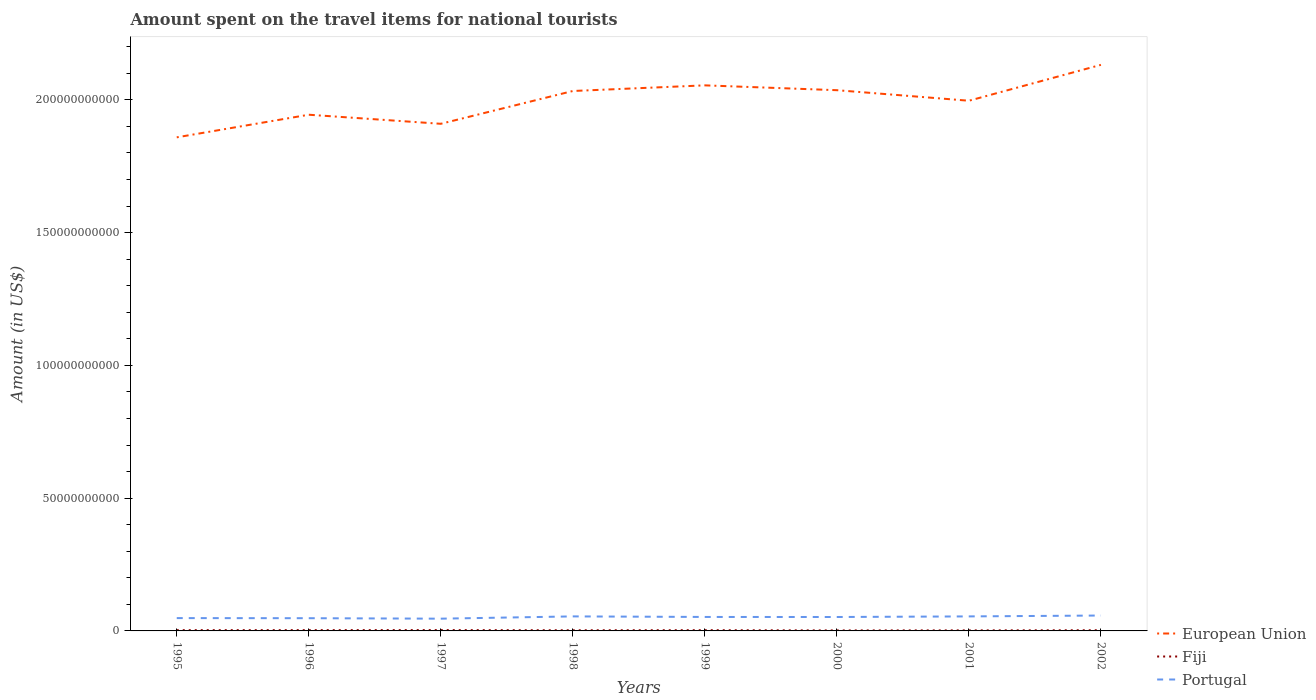How many different coloured lines are there?
Offer a very short reply. 3. Does the line corresponding to European Union intersect with the line corresponding to Portugal?
Offer a very short reply. No. Across all years, what is the maximum amount spent on the travel items for national tourists in Fiji?
Your answer should be compact. 1.89e+08. What is the total amount spent on the travel items for national tourists in European Union in the graph?
Provide a short and direct response. -8.68e+09. What is the difference between the highest and the second highest amount spent on the travel items for national tourists in Portugal?
Give a very brief answer. 1.18e+09. Is the amount spent on the travel items for national tourists in European Union strictly greater than the amount spent on the travel items for national tourists in Portugal over the years?
Your answer should be very brief. No. How many years are there in the graph?
Keep it short and to the point. 8. What is the difference between two consecutive major ticks on the Y-axis?
Provide a short and direct response. 5.00e+1. Does the graph contain grids?
Provide a short and direct response. No. Where does the legend appear in the graph?
Give a very brief answer. Bottom right. What is the title of the graph?
Provide a short and direct response. Amount spent on the travel items for national tourists. What is the label or title of the Y-axis?
Your answer should be very brief. Amount (in US$). What is the Amount (in US$) in European Union in 1995?
Provide a succinct answer. 1.86e+11. What is the Amount (in US$) of Fiji in 1995?
Provide a succinct answer. 2.91e+08. What is the Amount (in US$) in Portugal in 1995?
Your response must be concise. 4.83e+09. What is the Amount (in US$) of European Union in 1996?
Your answer should be compact. 1.94e+11. What is the Amount (in US$) in Fiji in 1996?
Provide a short and direct response. 2.98e+08. What is the Amount (in US$) of Portugal in 1996?
Give a very brief answer. 4.79e+09. What is the Amount (in US$) of European Union in 1997?
Give a very brief answer. 1.91e+11. What is the Amount (in US$) of Fiji in 1997?
Offer a terse response. 3.17e+08. What is the Amount (in US$) of Portugal in 1997?
Provide a short and direct response. 4.61e+09. What is the Amount (in US$) in European Union in 1998?
Keep it short and to the point. 2.03e+11. What is the Amount (in US$) of Fiji in 1998?
Your response must be concise. 2.48e+08. What is the Amount (in US$) in Portugal in 1998?
Offer a very short reply. 5.47e+09. What is the Amount (in US$) in European Union in 1999?
Your answer should be very brief. 2.05e+11. What is the Amount (in US$) in Fiji in 1999?
Your response must be concise. 2.80e+08. What is the Amount (in US$) in Portugal in 1999?
Keep it short and to the point. 5.26e+09. What is the Amount (in US$) in European Union in 2000?
Provide a succinct answer. 2.04e+11. What is the Amount (in US$) in Fiji in 2000?
Offer a terse response. 1.89e+08. What is the Amount (in US$) of Portugal in 2000?
Keep it short and to the point. 5.24e+09. What is the Amount (in US$) of European Union in 2001?
Keep it short and to the point. 2.00e+11. What is the Amount (in US$) in Fiji in 2001?
Your answer should be compact. 2.05e+08. What is the Amount (in US$) of Portugal in 2001?
Provide a succinct answer. 5.47e+09. What is the Amount (in US$) in European Union in 2002?
Make the answer very short. 2.13e+11. What is the Amount (in US$) in Fiji in 2002?
Provide a short and direct response. 2.60e+08. What is the Amount (in US$) in Portugal in 2002?
Your answer should be compact. 5.80e+09. Across all years, what is the maximum Amount (in US$) in European Union?
Give a very brief answer. 2.13e+11. Across all years, what is the maximum Amount (in US$) in Fiji?
Make the answer very short. 3.17e+08. Across all years, what is the maximum Amount (in US$) of Portugal?
Provide a succinct answer. 5.80e+09. Across all years, what is the minimum Amount (in US$) of European Union?
Keep it short and to the point. 1.86e+11. Across all years, what is the minimum Amount (in US$) of Fiji?
Keep it short and to the point. 1.89e+08. Across all years, what is the minimum Amount (in US$) in Portugal?
Provide a succinct answer. 4.61e+09. What is the total Amount (in US$) in European Union in the graph?
Ensure brevity in your answer.  1.60e+12. What is the total Amount (in US$) of Fiji in the graph?
Provide a succinct answer. 2.09e+09. What is the total Amount (in US$) in Portugal in the graph?
Offer a terse response. 4.15e+1. What is the difference between the Amount (in US$) in European Union in 1995 and that in 1996?
Provide a succinct answer. -8.51e+09. What is the difference between the Amount (in US$) of Fiji in 1995 and that in 1996?
Provide a succinct answer. -7.00e+06. What is the difference between the Amount (in US$) in Portugal in 1995 and that in 1996?
Your response must be concise. 4.00e+07. What is the difference between the Amount (in US$) of European Union in 1995 and that in 1997?
Provide a succinct answer. -5.10e+09. What is the difference between the Amount (in US$) of Fiji in 1995 and that in 1997?
Your answer should be very brief. -2.60e+07. What is the difference between the Amount (in US$) in Portugal in 1995 and that in 1997?
Provide a succinct answer. 2.17e+08. What is the difference between the Amount (in US$) in European Union in 1995 and that in 1998?
Provide a short and direct response. -1.75e+1. What is the difference between the Amount (in US$) of Fiji in 1995 and that in 1998?
Offer a terse response. 4.30e+07. What is the difference between the Amount (in US$) in Portugal in 1995 and that in 1998?
Your answer should be compact. -6.39e+08. What is the difference between the Amount (in US$) of European Union in 1995 and that in 1999?
Ensure brevity in your answer.  -1.96e+1. What is the difference between the Amount (in US$) of Fiji in 1995 and that in 1999?
Make the answer very short. 1.10e+07. What is the difference between the Amount (in US$) of Portugal in 1995 and that in 1999?
Offer a terse response. -4.29e+08. What is the difference between the Amount (in US$) in European Union in 1995 and that in 2000?
Keep it short and to the point. -1.78e+1. What is the difference between the Amount (in US$) in Fiji in 1995 and that in 2000?
Your response must be concise. 1.02e+08. What is the difference between the Amount (in US$) in Portugal in 1995 and that in 2000?
Your answer should be very brief. -4.12e+08. What is the difference between the Amount (in US$) in European Union in 1995 and that in 2001?
Give a very brief answer. -1.38e+1. What is the difference between the Amount (in US$) of Fiji in 1995 and that in 2001?
Make the answer very short. 8.60e+07. What is the difference between the Amount (in US$) in Portugal in 1995 and that in 2001?
Provide a short and direct response. -6.37e+08. What is the difference between the Amount (in US$) in European Union in 1995 and that in 2002?
Offer a terse response. -2.73e+1. What is the difference between the Amount (in US$) in Fiji in 1995 and that in 2002?
Keep it short and to the point. 3.10e+07. What is the difference between the Amount (in US$) of Portugal in 1995 and that in 2002?
Give a very brief answer. -9.67e+08. What is the difference between the Amount (in US$) of European Union in 1996 and that in 1997?
Offer a very short reply. 3.41e+09. What is the difference between the Amount (in US$) of Fiji in 1996 and that in 1997?
Keep it short and to the point. -1.90e+07. What is the difference between the Amount (in US$) in Portugal in 1996 and that in 1997?
Offer a terse response. 1.77e+08. What is the difference between the Amount (in US$) of European Union in 1996 and that in 1998?
Make the answer very short. -8.94e+09. What is the difference between the Amount (in US$) of Portugal in 1996 and that in 1998?
Provide a succinct answer. -6.79e+08. What is the difference between the Amount (in US$) in European Union in 1996 and that in 1999?
Offer a terse response. -1.11e+1. What is the difference between the Amount (in US$) in Fiji in 1996 and that in 1999?
Your answer should be very brief. 1.80e+07. What is the difference between the Amount (in US$) of Portugal in 1996 and that in 1999?
Your answer should be compact. -4.69e+08. What is the difference between the Amount (in US$) of European Union in 1996 and that in 2000?
Your answer should be compact. -9.24e+09. What is the difference between the Amount (in US$) in Fiji in 1996 and that in 2000?
Your response must be concise. 1.09e+08. What is the difference between the Amount (in US$) in Portugal in 1996 and that in 2000?
Keep it short and to the point. -4.52e+08. What is the difference between the Amount (in US$) in European Union in 1996 and that in 2001?
Provide a succinct answer. -5.27e+09. What is the difference between the Amount (in US$) in Fiji in 1996 and that in 2001?
Give a very brief answer. 9.30e+07. What is the difference between the Amount (in US$) of Portugal in 1996 and that in 2001?
Offer a terse response. -6.77e+08. What is the difference between the Amount (in US$) in European Union in 1996 and that in 2002?
Ensure brevity in your answer.  -1.88e+1. What is the difference between the Amount (in US$) of Fiji in 1996 and that in 2002?
Provide a succinct answer. 3.80e+07. What is the difference between the Amount (in US$) in Portugal in 1996 and that in 2002?
Offer a very short reply. -1.01e+09. What is the difference between the Amount (in US$) in European Union in 1997 and that in 1998?
Ensure brevity in your answer.  -1.24e+1. What is the difference between the Amount (in US$) of Fiji in 1997 and that in 1998?
Your response must be concise. 6.90e+07. What is the difference between the Amount (in US$) in Portugal in 1997 and that in 1998?
Offer a terse response. -8.56e+08. What is the difference between the Amount (in US$) in European Union in 1997 and that in 1999?
Ensure brevity in your answer.  -1.45e+1. What is the difference between the Amount (in US$) of Fiji in 1997 and that in 1999?
Provide a succinct answer. 3.70e+07. What is the difference between the Amount (in US$) of Portugal in 1997 and that in 1999?
Your answer should be compact. -6.46e+08. What is the difference between the Amount (in US$) of European Union in 1997 and that in 2000?
Give a very brief answer. -1.27e+1. What is the difference between the Amount (in US$) of Fiji in 1997 and that in 2000?
Make the answer very short. 1.28e+08. What is the difference between the Amount (in US$) of Portugal in 1997 and that in 2000?
Your answer should be very brief. -6.29e+08. What is the difference between the Amount (in US$) of European Union in 1997 and that in 2001?
Ensure brevity in your answer.  -8.68e+09. What is the difference between the Amount (in US$) of Fiji in 1997 and that in 2001?
Provide a short and direct response. 1.12e+08. What is the difference between the Amount (in US$) of Portugal in 1997 and that in 2001?
Keep it short and to the point. -8.54e+08. What is the difference between the Amount (in US$) of European Union in 1997 and that in 2002?
Make the answer very short. -2.22e+1. What is the difference between the Amount (in US$) in Fiji in 1997 and that in 2002?
Offer a terse response. 5.70e+07. What is the difference between the Amount (in US$) of Portugal in 1997 and that in 2002?
Ensure brevity in your answer.  -1.18e+09. What is the difference between the Amount (in US$) of European Union in 1998 and that in 1999?
Make the answer very short. -2.12e+09. What is the difference between the Amount (in US$) in Fiji in 1998 and that in 1999?
Make the answer very short. -3.20e+07. What is the difference between the Amount (in US$) of Portugal in 1998 and that in 1999?
Give a very brief answer. 2.10e+08. What is the difference between the Amount (in US$) in European Union in 1998 and that in 2000?
Your answer should be compact. -3.02e+08. What is the difference between the Amount (in US$) in Fiji in 1998 and that in 2000?
Keep it short and to the point. 5.90e+07. What is the difference between the Amount (in US$) of Portugal in 1998 and that in 2000?
Ensure brevity in your answer.  2.27e+08. What is the difference between the Amount (in US$) in European Union in 1998 and that in 2001?
Provide a succinct answer. 3.67e+09. What is the difference between the Amount (in US$) of Fiji in 1998 and that in 2001?
Your answer should be compact. 4.30e+07. What is the difference between the Amount (in US$) of European Union in 1998 and that in 2002?
Provide a succinct answer. -9.84e+09. What is the difference between the Amount (in US$) of Fiji in 1998 and that in 2002?
Keep it short and to the point. -1.20e+07. What is the difference between the Amount (in US$) of Portugal in 1998 and that in 2002?
Give a very brief answer. -3.28e+08. What is the difference between the Amount (in US$) in European Union in 1999 and that in 2000?
Your response must be concise. 1.82e+09. What is the difference between the Amount (in US$) in Fiji in 1999 and that in 2000?
Give a very brief answer. 9.10e+07. What is the difference between the Amount (in US$) of Portugal in 1999 and that in 2000?
Ensure brevity in your answer.  1.70e+07. What is the difference between the Amount (in US$) in European Union in 1999 and that in 2001?
Offer a terse response. 5.79e+09. What is the difference between the Amount (in US$) of Fiji in 1999 and that in 2001?
Make the answer very short. 7.50e+07. What is the difference between the Amount (in US$) in Portugal in 1999 and that in 2001?
Your response must be concise. -2.08e+08. What is the difference between the Amount (in US$) in European Union in 1999 and that in 2002?
Offer a terse response. -7.72e+09. What is the difference between the Amount (in US$) of Fiji in 1999 and that in 2002?
Offer a very short reply. 2.00e+07. What is the difference between the Amount (in US$) in Portugal in 1999 and that in 2002?
Provide a short and direct response. -5.38e+08. What is the difference between the Amount (in US$) in European Union in 2000 and that in 2001?
Your response must be concise. 3.97e+09. What is the difference between the Amount (in US$) in Fiji in 2000 and that in 2001?
Your response must be concise. -1.60e+07. What is the difference between the Amount (in US$) of Portugal in 2000 and that in 2001?
Offer a very short reply. -2.25e+08. What is the difference between the Amount (in US$) in European Union in 2000 and that in 2002?
Ensure brevity in your answer.  -9.54e+09. What is the difference between the Amount (in US$) of Fiji in 2000 and that in 2002?
Provide a short and direct response. -7.10e+07. What is the difference between the Amount (in US$) in Portugal in 2000 and that in 2002?
Provide a short and direct response. -5.55e+08. What is the difference between the Amount (in US$) in European Union in 2001 and that in 2002?
Provide a succinct answer. -1.35e+1. What is the difference between the Amount (in US$) of Fiji in 2001 and that in 2002?
Your answer should be compact. -5.50e+07. What is the difference between the Amount (in US$) of Portugal in 2001 and that in 2002?
Offer a terse response. -3.30e+08. What is the difference between the Amount (in US$) of European Union in 1995 and the Amount (in US$) of Fiji in 1996?
Your answer should be compact. 1.86e+11. What is the difference between the Amount (in US$) of European Union in 1995 and the Amount (in US$) of Portugal in 1996?
Offer a very short reply. 1.81e+11. What is the difference between the Amount (in US$) of Fiji in 1995 and the Amount (in US$) of Portugal in 1996?
Offer a terse response. -4.50e+09. What is the difference between the Amount (in US$) of European Union in 1995 and the Amount (in US$) of Fiji in 1997?
Provide a short and direct response. 1.86e+11. What is the difference between the Amount (in US$) in European Union in 1995 and the Amount (in US$) in Portugal in 1997?
Provide a short and direct response. 1.81e+11. What is the difference between the Amount (in US$) of Fiji in 1995 and the Amount (in US$) of Portugal in 1997?
Offer a very short reply. -4.32e+09. What is the difference between the Amount (in US$) of European Union in 1995 and the Amount (in US$) of Fiji in 1998?
Ensure brevity in your answer.  1.86e+11. What is the difference between the Amount (in US$) in European Union in 1995 and the Amount (in US$) in Portugal in 1998?
Keep it short and to the point. 1.80e+11. What is the difference between the Amount (in US$) of Fiji in 1995 and the Amount (in US$) of Portugal in 1998?
Offer a very short reply. -5.18e+09. What is the difference between the Amount (in US$) of European Union in 1995 and the Amount (in US$) of Fiji in 1999?
Offer a terse response. 1.86e+11. What is the difference between the Amount (in US$) in European Union in 1995 and the Amount (in US$) in Portugal in 1999?
Your response must be concise. 1.81e+11. What is the difference between the Amount (in US$) in Fiji in 1995 and the Amount (in US$) in Portugal in 1999?
Offer a very short reply. -4.97e+09. What is the difference between the Amount (in US$) of European Union in 1995 and the Amount (in US$) of Fiji in 2000?
Provide a succinct answer. 1.86e+11. What is the difference between the Amount (in US$) in European Union in 1995 and the Amount (in US$) in Portugal in 2000?
Your response must be concise. 1.81e+11. What is the difference between the Amount (in US$) of Fiji in 1995 and the Amount (in US$) of Portugal in 2000?
Make the answer very short. -4.95e+09. What is the difference between the Amount (in US$) in European Union in 1995 and the Amount (in US$) in Fiji in 2001?
Your answer should be very brief. 1.86e+11. What is the difference between the Amount (in US$) in European Union in 1995 and the Amount (in US$) in Portugal in 2001?
Your answer should be compact. 1.80e+11. What is the difference between the Amount (in US$) of Fiji in 1995 and the Amount (in US$) of Portugal in 2001?
Your response must be concise. -5.18e+09. What is the difference between the Amount (in US$) in European Union in 1995 and the Amount (in US$) in Fiji in 2002?
Provide a succinct answer. 1.86e+11. What is the difference between the Amount (in US$) in European Union in 1995 and the Amount (in US$) in Portugal in 2002?
Your answer should be compact. 1.80e+11. What is the difference between the Amount (in US$) of Fiji in 1995 and the Amount (in US$) of Portugal in 2002?
Your answer should be compact. -5.51e+09. What is the difference between the Amount (in US$) in European Union in 1996 and the Amount (in US$) in Fiji in 1997?
Ensure brevity in your answer.  1.94e+11. What is the difference between the Amount (in US$) of European Union in 1996 and the Amount (in US$) of Portugal in 1997?
Make the answer very short. 1.90e+11. What is the difference between the Amount (in US$) in Fiji in 1996 and the Amount (in US$) in Portugal in 1997?
Offer a very short reply. -4.32e+09. What is the difference between the Amount (in US$) in European Union in 1996 and the Amount (in US$) in Fiji in 1998?
Provide a succinct answer. 1.94e+11. What is the difference between the Amount (in US$) in European Union in 1996 and the Amount (in US$) in Portugal in 1998?
Keep it short and to the point. 1.89e+11. What is the difference between the Amount (in US$) in Fiji in 1996 and the Amount (in US$) in Portugal in 1998?
Your response must be concise. -5.17e+09. What is the difference between the Amount (in US$) in European Union in 1996 and the Amount (in US$) in Fiji in 1999?
Keep it short and to the point. 1.94e+11. What is the difference between the Amount (in US$) in European Union in 1996 and the Amount (in US$) in Portugal in 1999?
Your answer should be very brief. 1.89e+11. What is the difference between the Amount (in US$) of Fiji in 1996 and the Amount (in US$) of Portugal in 1999?
Ensure brevity in your answer.  -4.96e+09. What is the difference between the Amount (in US$) of European Union in 1996 and the Amount (in US$) of Fiji in 2000?
Your answer should be very brief. 1.94e+11. What is the difference between the Amount (in US$) in European Union in 1996 and the Amount (in US$) in Portugal in 2000?
Offer a very short reply. 1.89e+11. What is the difference between the Amount (in US$) of Fiji in 1996 and the Amount (in US$) of Portugal in 2000?
Your response must be concise. -4.94e+09. What is the difference between the Amount (in US$) in European Union in 1996 and the Amount (in US$) in Fiji in 2001?
Keep it short and to the point. 1.94e+11. What is the difference between the Amount (in US$) of European Union in 1996 and the Amount (in US$) of Portugal in 2001?
Give a very brief answer. 1.89e+11. What is the difference between the Amount (in US$) in Fiji in 1996 and the Amount (in US$) in Portugal in 2001?
Offer a terse response. -5.17e+09. What is the difference between the Amount (in US$) of European Union in 1996 and the Amount (in US$) of Fiji in 2002?
Provide a short and direct response. 1.94e+11. What is the difference between the Amount (in US$) of European Union in 1996 and the Amount (in US$) of Portugal in 2002?
Your answer should be very brief. 1.89e+11. What is the difference between the Amount (in US$) in Fiji in 1996 and the Amount (in US$) in Portugal in 2002?
Ensure brevity in your answer.  -5.50e+09. What is the difference between the Amount (in US$) in European Union in 1997 and the Amount (in US$) in Fiji in 1998?
Offer a very short reply. 1.91e+11. What is the difference between the Amount (in US$) in European Union in 1997 and the Amount (in US$) in Portugal in 1998?
Provide a short and direct response. 1.86e+11. What is the difference between the Amount (in US$) in Fiji in 1997 and the Amount (in US$) in Portugal in 1998?
Your answer should be compact. -5.15e+09. What is the difference between the Amount (in US$) of European Union in 1997 and the Amount (in US$) of Fiji in 1999?
Offer a terse response. 1.91e+11. What is the difference between the Amount (in US$) in European Union in 1997 and the Amount (in US$) in Portugal in 1999?
Make the answer very short. 1.86e+11. What is the difference between the Amount (in US$) in Fiji in 1997 and the Amount (in US$) in Portugal in 1999?
Offer a very short reply. -4.94e+09. What is the difference between the Amount (in US$) in European Union in 1997 and the Amount (in US$) in Fiji in 2000?
Offer a very short reply. 1.91e+11. What is the difference between the Amount (in US$) of European Union in 1997 and the Amount (in US$) of Portugal in 2000?
Keep it short and to the point. 1.86e+11. What is the difference between the Amount (in US$) of Fiji in 1997 and the Amount (in US$) of Portugal in 2000?
Offer a very short reply. -4.93e+09. What is the difference between the Amount (in US$) in European Union in 1997 and the Amount (in US$) in Fiji in 2001?
Make the answer very short. 1.91e+11. What is the difference between the Amount (in US$) of European Union in 1997 and the Amount (in US$) of Portugal in 2001?
Provide a succinct answer. 1.86e+11. What is the difference between the Amount (in US$) of Fiji in 1997 and the Amount (in US$) of Portugal in 2001?
Offer a very short reply. -5.15e+09. What is the difference between the Amount (in US$) of European Union in 1997 and the Amount (in US$) of Fiji in 2002?
Give a very brief answer. 1.91e+11. What is the difference between the Amount (in US$) of European Union in 1997 and the Amount (in US$) of Portugal in 2002?
Provide a succinct answer. 1.85e+11. What is the difference between the Amount (in US$) of Fiji in 1997 and the Amount (in US$) of Portugal in 2002?
Offer a very short reply. -5.48e+09. What is the difference between the Amount (in US$) of European Union in 1998 and the Amount (in US$) of Fiji in 1999?
Provide a short and direct response. 2.03e+11. What is the difference between the Amount (in US$) in European Union in 1998 and the Amount (in US$) in Portugal in 1999?
Your response must be concise. 1.98e+11. What is the difference between the Amount (in US$) in Fiji in 1998 and the Amount (in US$) in Portugal in 1999?
Your answer should be compact. -5.01e+09. What is the difference between the Amount (in US$) in European Union in 1998 and the Amount (in US$) in Fiji in 2000?
Ensure brevity in your answer.  2.03e+11. What is the difference between the Amount (in US$) of European Union in 1998 and the Amount (in US$) of Portugal in 2000?
Keep it short and to the point. 1.98e+11. What is the difference between the Amount (in US$) of Fiji in 1998 and the Amount (in US$) of Portugal in 2000?
Ensure brevity in your answer.  -5.00e+09. What is the difference between the Amount (in US$) in European Union in 1998 and the Amount (in US$) in Fiji in 2001?
Your response must be concise. 2.03e+11. What is the difference between the Amount (in US$) in European Union in 1998 and the Amount (in US$) in Portugal in 2001?
Keep it short and to the point. 1.98e+11. What is the difference between the Amount (in US$) in Fiji in 1998 and the Amount (in US$) in Portugal in 2001?
Ensure brevity in your answer.  -5.22e+09. What is the difference between the Amount (in US$) in European Union in 1998 and the Amount (in US$) in Fiji in 2002?
Offer a very short reply. 2.03e+11. What is the difference between the Amount (in US$) of European Union in 1998 and the Amount (in US$) of Portugal in 2002?
Make the answer very short. 1.98e+11. What is the difference between the Amount (in US$) in Fiji in 1998 and the Amount (in US$) in Portugal in 2002?
Give a very brief answer. -5.55e+09. What is the difference between the Amount (in US$) in European Union in 1999 and the Amount (in US$) in Fiji in 2000?
Give a very brief answer. 2.05e+11. What is the difference between the Amount (in US$) in European Union in 1999 and the Amount (in US$) in Portugal in 2000?
Make the answer very short. 2.00e+11. What is the difference between the Amount (in US$) of Fiji in 1999 and the Amount (in US$) of Portugal in 2000?
Ensure brevity in your answer.  -4.96e+09. What is the difference between the Amount (in US$) of European Union in 1999 and the Amount (in US$) of Fiji in 2001?
Give a very brief answer. 2.05e+11. What is the difference between the Amount (in US$) in European Union in 1999 and the Amount (in US$) in Portugal in 2001?
Your answer should be compact. 2.00e+11. What is the difference between the Amount (in US$) in Fiji in 1999 and the Amount (in US$) in Portugal in 2001?
Make the answer very short. -5.19e+09. What is the difference between the Amount (in US$) in European Union in 1999 and the Amount (in US$) in Fiji in 2002?
Keep it short and to the point. 2.05e+11. What is the difference between the Amount (in US$) in European Union in 1999 and the Amount (in US$) in Portugal in 2002?
Your response must be concise. 2.00e+11. What is the difference between the Amount (in US$) in Fiji in 1999 and the Amount (in US$) in Portugal in 2002?
Ensure brevity in your answer.  -5.52e+09. What is the difference between the Amount (in US$) of European Union in 2000 and the Amount (in US$) of Fiji in 2001?
Your response must be concise. 2.03e+11. What is the difference between the Amount (in US$) in European Union in 2000 and the Amount (in US$) in Portugal in 2001?
Your answer should be compact. 1.98e+11. What is the difference between the Amount (in US$) of Fiji in 2000 and the Amount (in US$) of Portugal in 2001?
Your response must be concise. -5.28e+09. What is the difference between the Amount (in US$) in European Union in 2000 and the Amount (in US$) in Fiji in 2002?
Make the answer very short. 2.03e+11. What is the difference between the Amount (in US$) in European Union in 2000 and the Amount (in US$) in Portugal in 2002?
Your answer should be compact. 1.98e+11. What is the difference between the Amount (in US$) of Fiji in 2000 and the Amount (in US$) of Portugal in 2002?
Ensure brevity in your answer.  -5.61e+09. What is the difference between the Amount (in US$) of European Union in 2001 and the Amount (in US$) of Fiji in 2002?
Keep it short and to the point. 1.99e+11. What is the difference between the Amount (in US$) of European Union in 2001 and the Amount (in US$) of Portugal in 2002?
Make the answer very short. 1.94e+11. What is the difference between the Amount (in US$) in Fiji in 2001 and the Amount (in US$) in Portugal in 2002?
Your answer should be compact. -5.59e+09. What is the average Amount (in US$) of European Union per year?
Ensure brevity in your answer.  2.00e+11. What is the average Amount (in US$) of Fiji per year?
Offer a terse response. 2.61e+08. What is the average Amount (in US$) of Portugal per year?
Give a very brief answer. 5.18e+09. In the year 1995, what is the difference between the Amount (in US$) in European Union and Amount (in US$) in Fiji?
Offer a very short reply. 1.86e+11. In the year 1995, what is the difference between the Amount (in US$) in European Union and Amount (in US$) in Portugal?
Ensure brevity in your answer.  1.81e+11. In the year 1995, what is the difference between the Amount (in US$) in Fiji and Amount (in US$) in Portugal?
Ensure brevity in your answer.  -4.54e+09. In the year 1996, what is the difference between the Amount (in US$) in European Union and Amount (in US$) in Fiji?
Keep it short and to the point. 1.94e+11. In the year 1996, what is the difference between the Amount (in US$) in European Union and Amount (in US$) in Portugal?
Make the answer very short. 1.90e+11. In the year 1996, what is the difference between the Amount (in US$) of Fiji and Amount (in US$) of Portugal?
Your answer should be compact. -4.49e+09. In the year 1997, what is the difference between the Amount (in US$) in European Union and Amount (in US$) in Fiji?
Provide a short and direct response. 1.91e+11. In the year 1997, what is the difference between the Amount (in US$) of European Union and Amount (in US$) of Portugal?
Make the answer very short. 1.86e+11. In the year 1997, what is the difference between the Amount (in US$) of Fiji and Amount (in US$) of Portugal?
Provide a short and direct response. -4.30e+09. In the year 1998, what is the difference between the Amount (in US$) in European Union and Amount (in US$) in Fiji?
Your answer should be very brief. 2.03e+11. In the year 1998, what is the difference between the Amount (in US$) in European Union and Amount (in US$) in Portugal?
Keep it short and to the point. 1.98e+11. In the year 1998, what is the difference between the Amount (in US$) of Fiji and Amount (in US$) of Portugal?
Offer a terse response. -5.22e+09. In the year 1999, what is the difference between the Amount (in US$) of European Union and Amount (in US$) of Fiji?
Give a very brief answer. 2.05e+11. In the year 1999, what is the difference between the Amount (in US$) in European Union and Amount (in US$) in Portugal?
Your answer should be compact. 2.00e+11. In the year 1999, what is the difference between the Amount (in US$) in Fiji and Amount (in US$) in Portugal?
Keep it short and to the point. -4.98e+09. In the year 2000, what is the difference between the Amount (in US$) in European Union and Amount (in US$) in Fiji?
Your answer should be very brief. 2.03e+11. In the year 2000, what is the difference between the Amount (in US$) of European Union and Amount (in US$) of Portugal?
Make the answer very short. 1.98e+11. In the year 2000, what is the difference between the Amount (in US$) in Fiji and Amount (in US$) in Portugal?
Offer a terse response. -5.05e+09. In the year 2001, what is the difference between the Amount (in US$) of European Union and Amount (in US$) of Fiji?
Make the answer very short. 1.99e+11. In the year 2001, what is the difference between the Amount (in US$) in European Union and Amount (in US$) in Portugal?
Your answer should be compact. 1.94e+11. In the year 2001, what is the difference between the Amount (in US$) in Fiji and Amount (in US$) in Portugal?
Make the answer very short. -5.26e+09. In the year 2002, what is the difference between the Amount (in US$) of European Union and Amount (in US$) of Fiji?
Your answer should be very brief. 2.13e+11. In the year 2002, what is the difference between the Amount (in US$) in European Union and Amount (in US$) in Portugal?
Ensure brevity in your answer.  2.07e+11. In the year 2002, what is the difference between the Amount (in US$) in Fiji and Amount (in US$) in Portugal?
Ensure brevity in your answer.  -5.54e+09. What is the ratio of the Amount (in US$) of European Union in 1995 to that in 1996?
Keep it short and to the point. 0.96. What is the ratio of the Amount (in US$) in Fiji in 1995 to that in 1996?
Your answer should be very brief. 0.98. What is the ratio of the Amount (in US$) of Portugal in 1995 to that in 1996?
Your response must be concise. 1.01. What is the ratio of the Amount (in US$) in European Union in 1995 to that in 1997?
Your answer should be compact. 0.97. What is the ratio of the Amount (in US$) in Fiji in 1995 to that in 1997?
Make the answer very short. 0.92. What is the ratio of the Amount (in US$) of Portugal in 1995 to that in 1997?
Provide a succinct answer. 1.05. What is the ratio of the Amount (in US$) in European Union in 1995 to that in 1998?
Ensure brevity in your answer.  0.91. What is the ratio of the Amount (in US$) of Fiji in 1995 to that in 1998?
Provide a short and direct response. 1.17. What is the ratio of the Amount (in US$) of Portugal in 1995 to that in 1998?
Provide a succinct answer. 0.88. What is the ratio of the Amount (in US$) of European Union in 1995 to that in 1999?
Offer a terse response. 0.9. What is the ratio of the Amount (in US$) in Fiji in 1995 to that in 1999?
Give a very brief answer. 1.04. What is the ratio of the Amount (in US$) in Portugal in 1995 to that in 1999?
Provide a succinct answer. 0.92. What is the ratio of the Amount (in US$) in European Union in 1995 to that in 2000?
Ensure brevity in your answer.  0.91. What is the ratio of the Amount (in US$) of Fiji in 1995 to that in 2000?
Provide a succinct answer. 1.54. What is the ratio of the Amount (in US$) in Portugal in 1995 to that in 2000?
Offer a terse response. 0.92. What is the ratio of the Amount (in US$) of Fiji in 1995 to that in 2001?
Offer a terse response. 1.42. What is the ratio of the Amount (in US$) in Portugal in 1995 to that in 2001?
Make the answer very short. 0.88. What is the ratio of the Amount (in US$) in European Union in 1995 to that in 2002?
Your answer should be very brief. 0.87. What is the ratio of the Amount (in US$) in Fiji in 1995 to that in 2002?
Your answer should be very brief. 1.12. What is the ratio of the Amount (in US$) of Portugal in 1995 to that in 2002?
Make the answer very short. 0.83. What is the ratio of the Amount (in US$) of European Union in 1996 to that in 1997?
Your response must be concise. 1.02. What is the ratio of the Amount (in US$) of Fiji in 1996 to that in 1997?
Offer a very short reply. 0.94. What is the ratio of the Amount (in US$) of Portugal in 1996 to that in 1997?
Ensure brevity in your answer.  1.04. What is the ratio of the Amount (in US$) in European Union in 1996 to that in 1998?
Ensure brevity in your answer.  0.96. What is the ratio of the Amount (in US$) in Fiji in 1996 to that in 1998?
Ensure brevity in your answer.  1.2. What is the ratio of the Amount (in US$) in Portugal in 1996 to that in 1998?
Your response must be concise. 0.88. What is the ratio of the Amount (in US$) of European Union in 1996 to that in 1999?
Your response must be concise. 0.95. What is the ratio of the Amount (in US$) in Fiji in 1996 to that in 1999?
Offer a very short reply. 1.06. What is the ratio of the Amount (in US$) of Portugal in 1996 to that in 1999?
Ensure brevity in your answer.  0.91. What is the ratio of the Amount (in US$) in European Union in 1996 to that in 2000?
Offer a very short reply. 0.95. What is the ratio of the Amount (in US$) of Fiji in 1996 to that in 2000?
Give a very brief answer. 1.58. What is the ratio of the Amount (in US$) of Portugal in 1996 to that in 2000?
Offer a terse response. 0.91. What is the ratio of the Amount (in US$) in European Union in 1996 to that in 2001?
Your response must be concise. 0.97. What is the ratio of the Amount (in US$) in Fiji in 1996 to that in 2001?
Provide a succinct answer. 1.45. What is the ratio of the Amount (in US$) of Portugal in 1996 to that in 2001?
Provide a succinct answer. 0.88. What is the ratio of the Amount (in US$) of European Union in 1996 to that in 2002?
Provide a succinct answer. 0.91. What is the ratio of the Amount (in US$) of Fiji in 1996 to that in 2002?
Offer a terse response. 1.15. What is the ratio of the Amount (in US$) in Portugal in 1996 to that in 2002?
Offer a very short reply. 0.83. What is the ratio of the Amount (in US$) in European Union in 1997 to that in 1998?
Your answer should be compact. 0.94. What is the ratio of the Amount (in US$) in Fiji in 1997 to that in 1998?
Ensure brevity in your answer.  1.28. What is the ratio of the Amount (in US$) in Portugal in 1997 to that in 1998?
Your answer should be very brief. 0.84. What is the ratio of the Amount (in US$) of European Union in 1997 to that in 1999?
Make the answer very short. 0.93. What is the ratio of the Amount (in US$) in Fiji in 1997 to that in 1999?
Your answer should be very brief. 1.13. What is the ratio of the Amount (in US$) in Portugal in 1997 to that in 1999?
Your response must be concise. 0.88. What is the ratio of the Amount (in US$) of European Union in 1997 to that in 2000?
Offer a terse response. 0.94. What is the ratio of the Amount (in US$) in Fiji in 1997 to that in 2000?
Your response must be concise. 1.68. What is the ratio of the Amount (in US$) of European Union in 1997 to that in 2001?
Provide a short and direct response. 0.96. What is the ratio of the Amount (in US$) in Fiji in 1997 to that in 2001?
Provide a short and direct response. 1.55. What is the ratio of the Amount (in US$) in Portugal in 1997 to that in 2001?
Your answer should be very brief. 0.84. What is the ratio of the Amount (in US$) of European Union in 1997 to that in 2002?
Your response must be concise. 0.9. What is the ratio of the Amount (in US$) of Fiji in 1997 to that in 2002?
Provide a succinct answer. 1.22. What is the ratio of the Amount (in US$) of Portugal in 1997 to that in 2002?
Keep it short and to the point. 0.8. What is the ratio of the Amount (in US$) in Fiji in 1998 to that in 1999?
Your response must be concise. 0.89. What is the ratio of the Amount (in US$) of Portugal in 1998 to that in 1999?
Offer a very short reply. 1.04. What is the ratio of the Amount (in US$) of European Union in 1998 to that in 2000?
Your response must be concise. 1. What is the ratio of the Amount (in US$) of Fiji in 1998 to that in 2000?
Ensure brevity in your answer.  1.31. What is the ratio of the Amount (in US$) of Portugal in 1998 to that in 2000?
Your response must be concise. 1.04. What is the ratio of the Amount (in US$) in European Union in 1998 to that in 2001?
Offer a very short reply. 1.02. What is the ratio of the Amount (in US$) in Fiji in 1998 to that in 2001?
Your answer should be compact. 1.21. What is the ratio of the Amount (in US$) of Portugal in 1998 to that in 2001?
Your response must be concise. 1. What is the ratio of the Amount (in US$) in European Union in 1998 to that in 2002?
Provide a succinct answer. 0.95. What is the ratio of the Amount (in US$) of Fiji in 1998 to that in 2002?
Provide a short and direct response. 0.95. What is the ratio of the Amount (in US$) of Portugal in 1998 to that in 2002?
Your answer should be very brief. 0.94. What is the ratio of the Amount (in US$) in European Union in 1999 to that in 2000?
Keep it short and to the point. 1.01. What is the ratio of the Amount (in US$) in Fiji in 1999 to that in 2000?
Your answer should be very brief. 1.48. What is the ratio of the Amount (in US$) of European Union in 1999 to that in 2001?
Offer a terse response. 1.03. What is the ratio of the Amount (in US$) in Fiji in 1999 to that in 2001?
Keep it short and to the point. 1.37. What is the ratio of the Amount (in US$) in Portugal in 1999 to that in 2001?
Offer a very short reply. 0.96. What is the ratio of the Amount (in US$) of European Union in 1999 to that in 2002?
Provide a short and direct response. 0.96. What is the ratio of the Amount (in US$) of Portugal in 1999 to that in 2002?
Your response must be concise. 0.91. What is the ratio of the Amount (in US$) of European Union in 2000 to that in 2001?
Your answer should be very brief. 1.02. What is the ratio of the Amount (in US$) of Fiji in 2000 to that in 2001?
Make the answer very short. 0.92. What is the ratio of the Amount (in US$) in Portugal in 2000 to that in 2001?
Your answer should be very brief. 0.96. What is the ratio of the Amount (in US$) of European Union in 2000 to that in 2002?
Make the answer very short. 0.96. What is the ratio of the Amount (in US$) of Fiji in 2000 to that in 2002?
Your response must be concise. 0.73. What is the ratio of the Amount (in US$) of Portugal in 2000 to that in 2002?
Ensure brevity in your answer.  0.9. What is the ratio of the Amount (in US$) of European Union in 2001 to that in 2002?
Offer a terse response. 0.94. What is the ratio of the Amount (in US$) in Fiji in 2001 to that in 2002?
Offer a terse response. 0.79. What is the ratio of the Amount (in US$) of Portugal in 2001 to that in 2002?
Provide a succinct answer. 0.94. What is the difference between the highest and the second highest Amount (in US$) of European Union?
Offer a very short reply. 7.72e+09. What is the difference between the highest and the second highest Amount (in US$) of Fiji?
Your answer should be compact. 1.90e+07. What is the difference between the highest and the second highest Amount (in US$) in Portugal?
Your answer should be very brief. 3.28e+08. What is the difference between the highest and the lowest Amount (in US$) of European Union?
Give a very brief answer. 2.73e+1. What is the difference between the highest and the lowest Amount (in US$) in Fiji?
Your response must be concise. 1.28e+08. What is the difference between the highest and the lowest Amount (in US$) of Portugal?
Provide a short and direct response. 1.18e+09. 